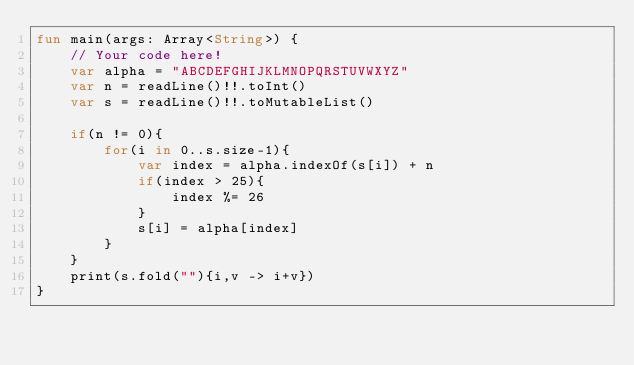Convert code to text. <code><loc_0><loc_0><loc_500><loc_500><_Kotlin_>fun main(args: Array<String>) {
    // Your code here!
    var alpha = "ABCDEFGHIJKLMNOPQRSTUVWXYZ" 
    var n = readLine()!!.toInt()
    var s = readLine()!!.toMutableList()
    
    if(n != 0){
        for(i in 0..s.size-1){
            var index = alpha.indexOf(s[i]) + n
            if(index > 25){
                index %= 26
            }
            s[i] = alpha[index]
        }
    }
    print(s.fold(""){i,v -> i+v})
}
</code> 